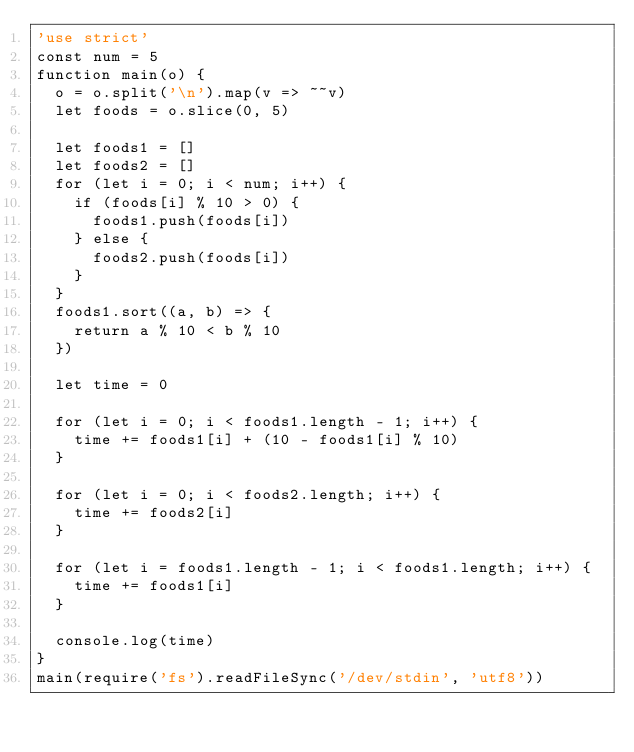Convert code to text. <code><loc_0><loc_0><loc_500><loc_500><_JavaScript_>'use strict'
const num = 5
function main(o) {
  o = o.split('\n').map(v => ~~v)
  let foods = o.slice(0, 5)

  let foods1 = []
  let foods2 = []
  for (let i = 0; i < num; i++) {
    if (foods[i] % 10 > 0) {
      foods1.push(foods[i])
    } else {
      foods2.push(foods[i])
    }
  }
  foods1.sort((a, b) => {
    return a % 10 < b % 10
  })

  let time = 0

  for (let i = 0; i < foods1.length - 1; i++) {
    time += foods1[i] + (10 - foods1[i] % 10)
  }

  for (let i = 0; i < foods2.length; i++) {
    time += foods2[i]
  }

  for (let i = foods1.length - 1; i < foods1.length; i++) {
    time += foods1[i]
  }

  console.log(time)
}
main(require('fs').readFileSync('/dev/stdin', 'utf8'))
</code> 